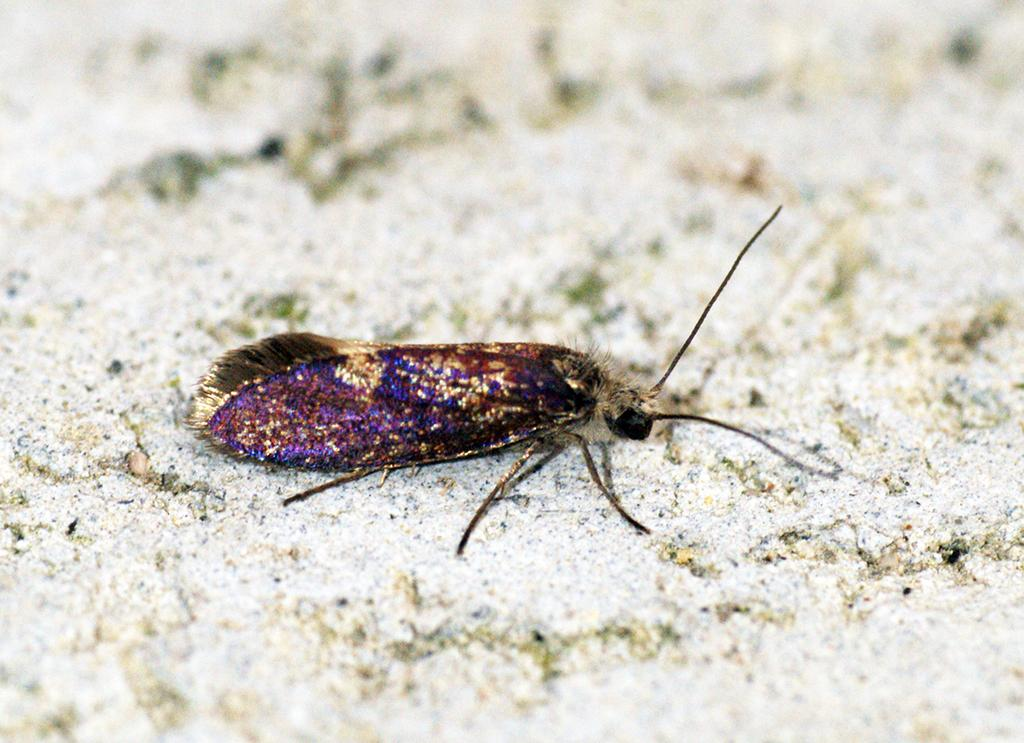What type of creature can be seen in the image? There is an insect in the image. What is the insect's environment in the image? The insect is on a sand surface. What account number is associated with the insect in the image? There is no account number associated with the insect in the image, as it is a living creature and not a financial entity. 